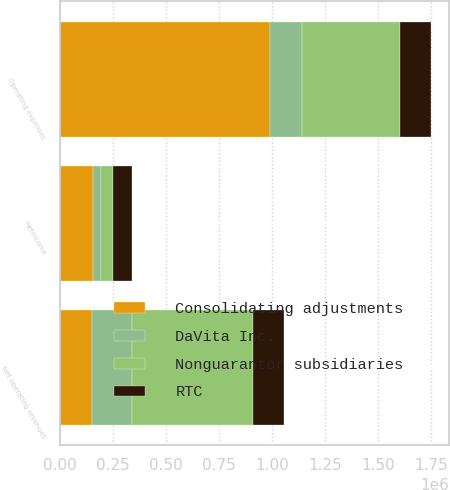Convert chart. <chart><loc_0><loc_0><loc_500><loc_500><stacked_bar_chart><ecel><fcel>Net operating revenues<fcel>Operating expenses<fcel>Netincome<nl><fcel>Consolidating adjustments<fcel>151291<fcel>990504<fcel>157329<nl><fcel>Nonguarantor subsidiaries<fcel>570658<fcel>464047<fcel>57812<nl><fcel>DaVita Inc.<fcel>190109<fcel>151291<fcel>34646<nl><fcel>RTC<fcel>142542<fcel>142542<fcel>92458<nl></chart> 